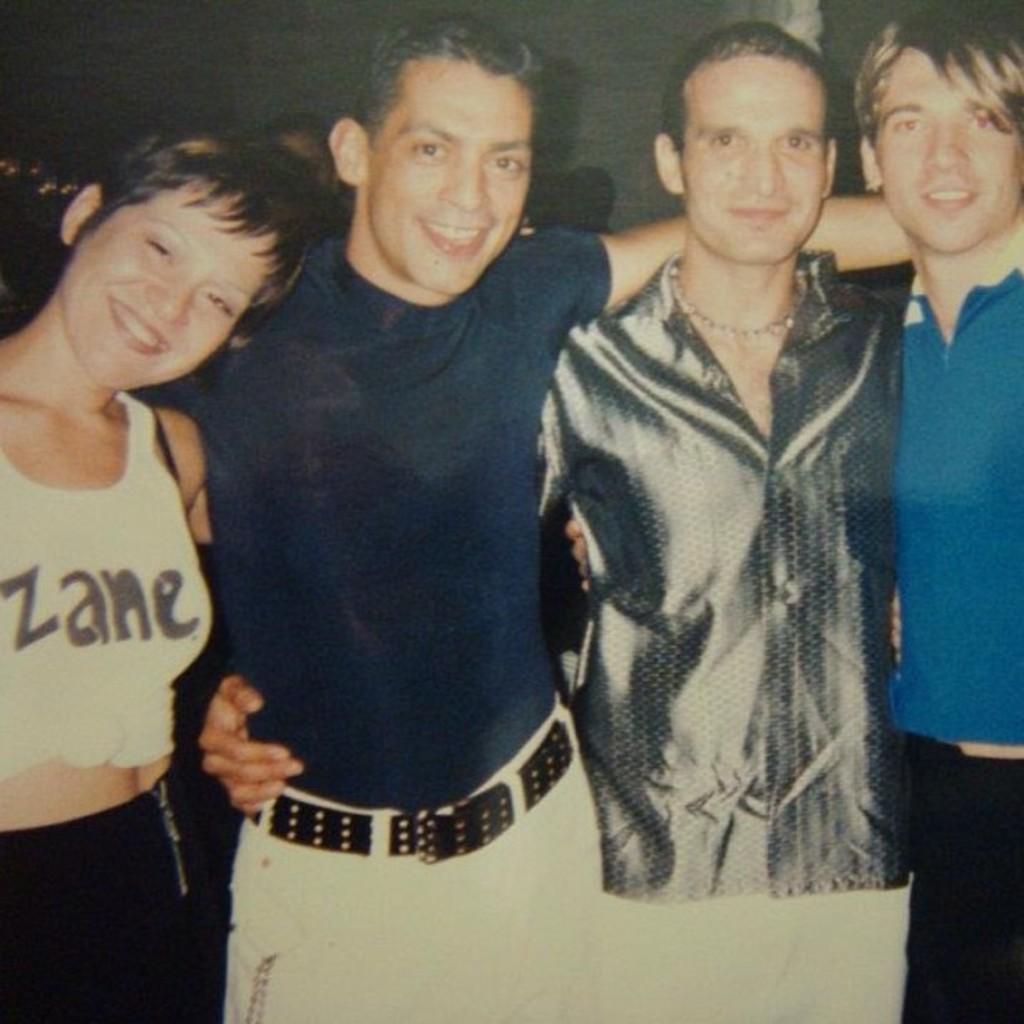Please provide a concise description of this image. In this image we can see some people are standing and posing. 